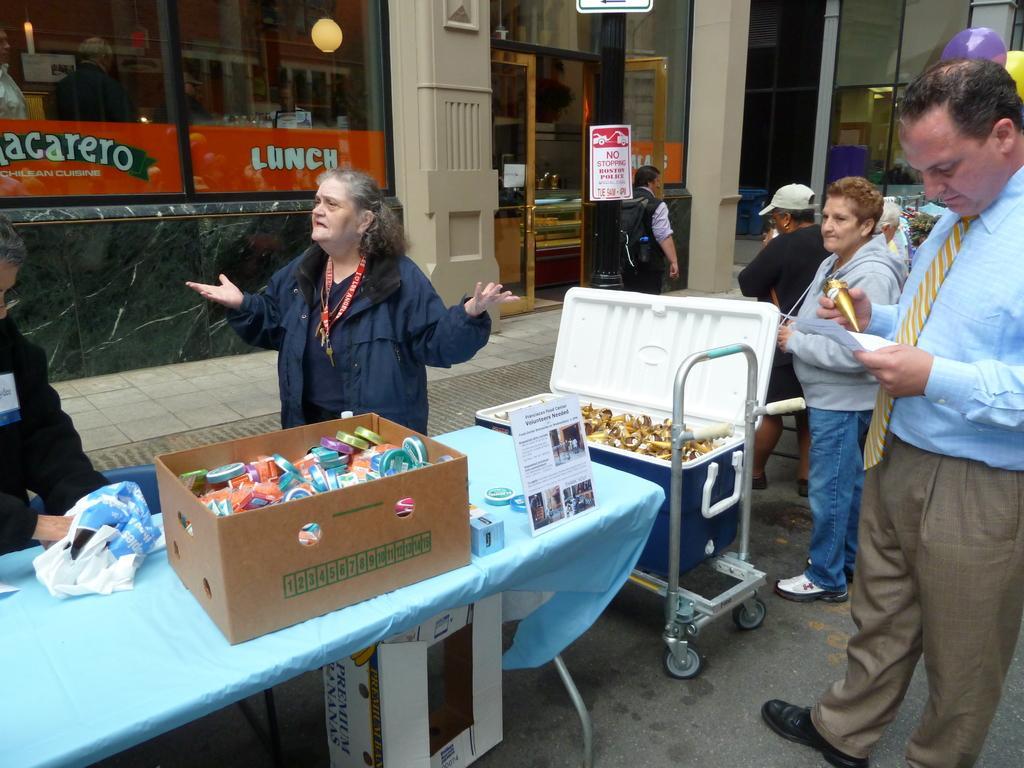Can you describe this image briefly? There are some people standing in this picture in front of a table. On the table there is a box which is containing some things in it. Beside the box there is a trolley on which one box is placed on it. In the background we can observe a wall and a board here to the pole. 